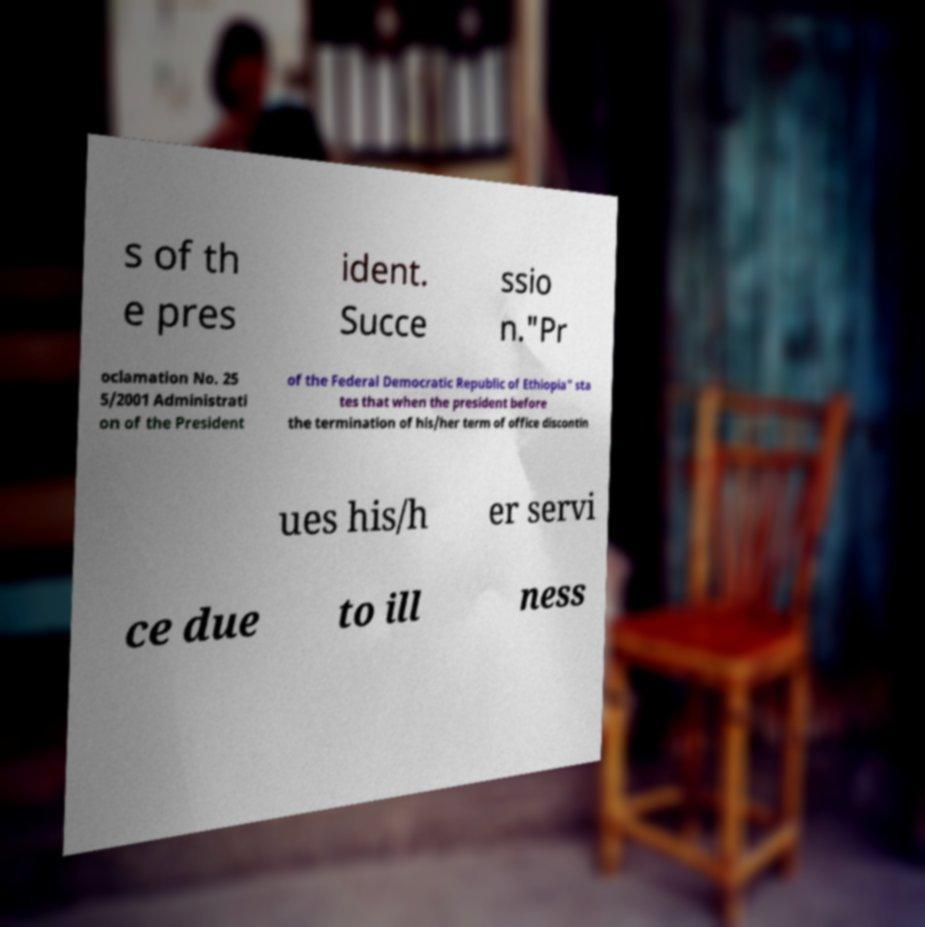For documentation purposes, I need the text within this image transcribed. Could you provide that? s of th e pres ident. Succe ssio n."Pr oclamation No. 25 5/2001 Administrati on of the President of the Federal Democratic Republic of Ethiopia" sta tes that when the president before the termination of his/her term of office discontin ues his/h er servi ce due to ill ness 